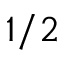Convert formula to latex. <formula><loc_0><loc_0><loc_500><loc_500>1 / 2</formula> 